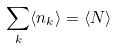<formula> <loc_0><loc_0><loc_500><loc_500>\sum _ { k } \langle n _ { k } \rangle = \langle N \rangle</formula> 